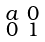<formula> <loc_0><loc_0><loc_500><loc_500>\begin{smallmatrix} a & 0 \\ 0 & 1 \end{smallmatrix}</formula> 